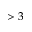Convert formula to latex. <formula><loc_0><loc_0><loc_500><loc_500>> 3</formula> 